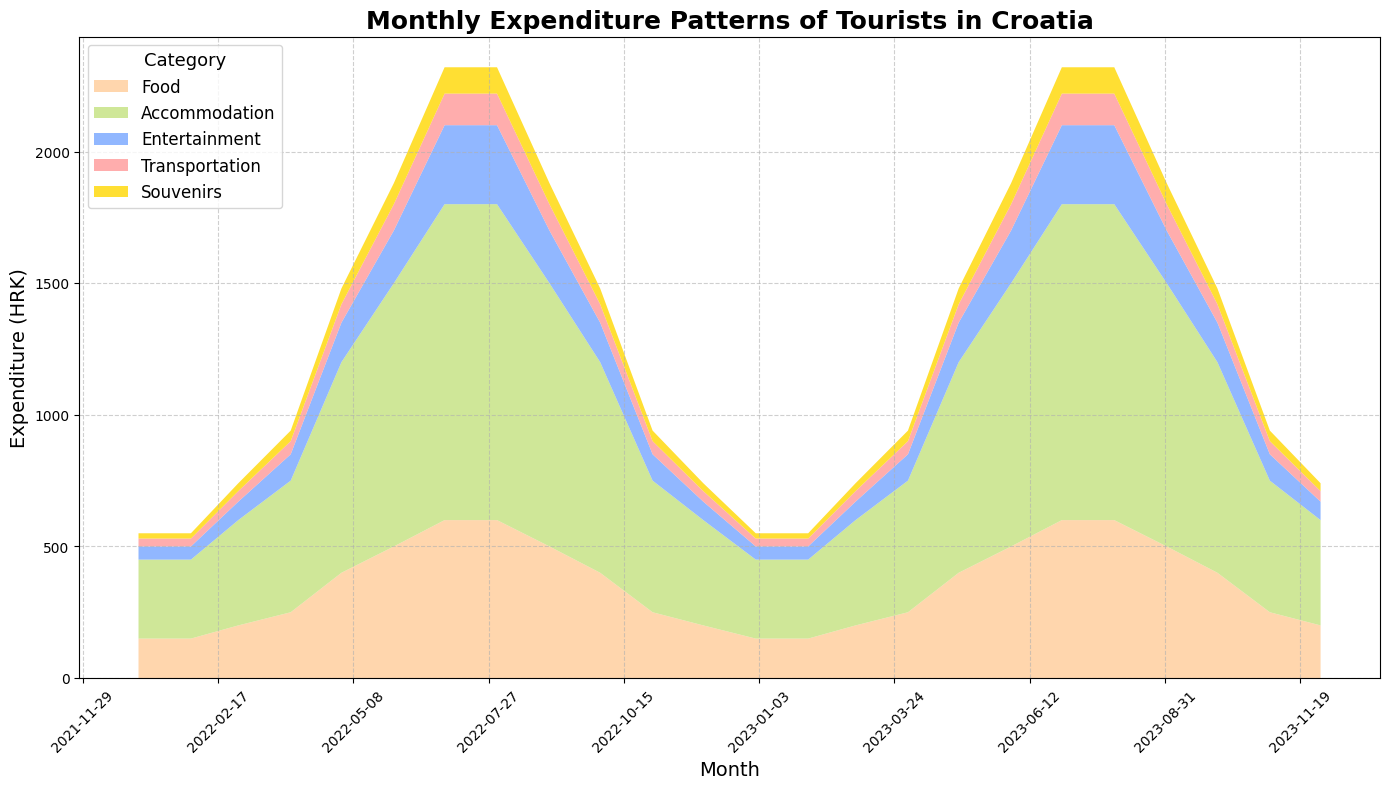Which month had the highest total tourist expenditure in 2022? To determine the month with the highest total expenditure, add up the expenditures in all categories for each month in 2022. The month with the highest sum will have the highest expenditure. The total for July 2022 is 600 (Food) + 1200 (Accommodation) + 300 (Entertainment) + 120 (Transportation) + 100 (Souvenirs) = 2320 HRK.
Answer: July 2022 How does the expenditure on food in August compare to that in December? The expenditure on food in August is 600 HRK, while in December it is 200 HRK. Comparing these, the expenditure on food in August is greater.
Answer: August > December What is the average monthly expenditure on entertainment in 2022? Sum the monthly expenditures on entertainment for all months in 2022 and divide by the number of months (12). The sum is 50 + 50 + 70 + 100 + 150 + 200 + 300 + 300 + 200 + 150 + 100 + 70 = 1740 HRK. The average is 1740 HRK / 12 ≈ 145 HRK.
Answer: 145 HRK Which category saw the highest increase in expenditures from January to July 2022? Calculate the increase for each category by subtracting January's expenditure from July's. The increases are: Food: 600 - 150 = 450, Accommodation: 1200 - 300 = 900, Entertainment: 300 - 50 = 250, Transportation: 120 - 30 = 90, Souvenirs: 100 - 20 = 80. Accommodation has the highest increase.
Answer: Accommodation What is the total expenditure on souvenirs for the months of June, July, and August 2023? Sum the monthly expenditures on souvenirs for June, July, and August 2023. The expenditures are 80 (June) + 100 (July) + 100 (August). The total is 80 + 100 + 100 = 280 HRK.
Answer: 280 HRK In which month did transportation costs peak and how much were they? The transportation costs can be seen to peak in July and August, both at 120 HRK.
Answer: July and August, 120 HRK Compare the trend of expenditure on accommodation from January to December 2022. Accommodation expenditures in 2022 start at 300 HRK in January, increase steadily, peaking at 1200 HRK in July and August, and then decrease back to 300 HRK by December.
Answer: Increasing, then decreasing Between food and souvenirs, which category consistently shows lower expenditure each month? By visual inspection of the lower ends of the chart, the expenditure on souvenirs is consistently lower each month compared to food.
Answer: Souvenirs What is the total expenditure for April 2023, and how does it compare to April 2022? Sum the expenditures for each category in April 2023 and April 2022. For April 2023, the total is 250 (Food) + 500 (Accommodation) + 100 (Entertainment) + 50 (Transportation) + 40 (Souvenirs) = 940 HRK. For April 2022, the total is the same at 940 HRK. Therefore, the expenditures are the same.
Answer: 940 HRK, same Which category had the smallest increase between May and June 2022? Calculate the increase for each category between May and June 2022. The increases are: Food: 500 - 400 = 100, Accommodation: 1000 - 800 = 200, Entertainment: 200 - 150 = 50, Transportation: 100 - 70 = 30, Souvenirs: 80 - 60 = 20. Transportation had the smallest increase.
Answer: Transportation 